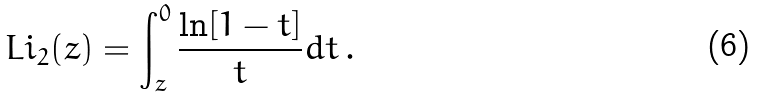Convert formula to latex. <formula><loc_0><loc_0><loc_500><loc_500>L i _ { 2 } ( z ) = \int ^ { 0 } _ { z } \frac { \ln [ 1 - t ] } { t } d t \, .</formula> 